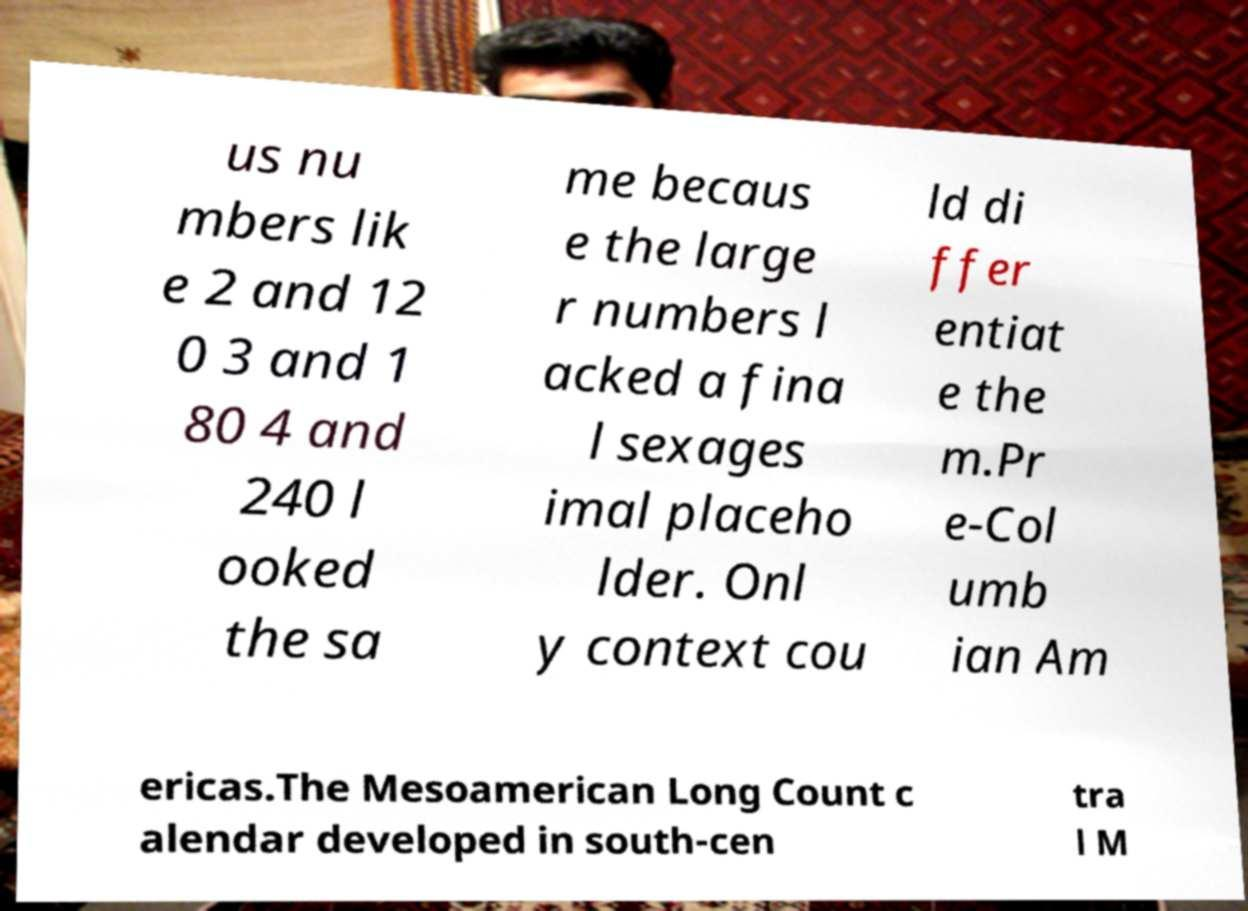I need the written content from this picture converted into text. Can you do that? us nu mbers lik e 2 and 12 0 3 and 1 80 4 and 240 l ooked the sa me becaus e the large r numbers l acked a fina l sexages imal placeho lder. Onl y context cou ld di ffer entiat e the m.Pr e-Col umb ian Am ericas.The Mesoamerican Long Count c alendar developed in south-cen tra l M 